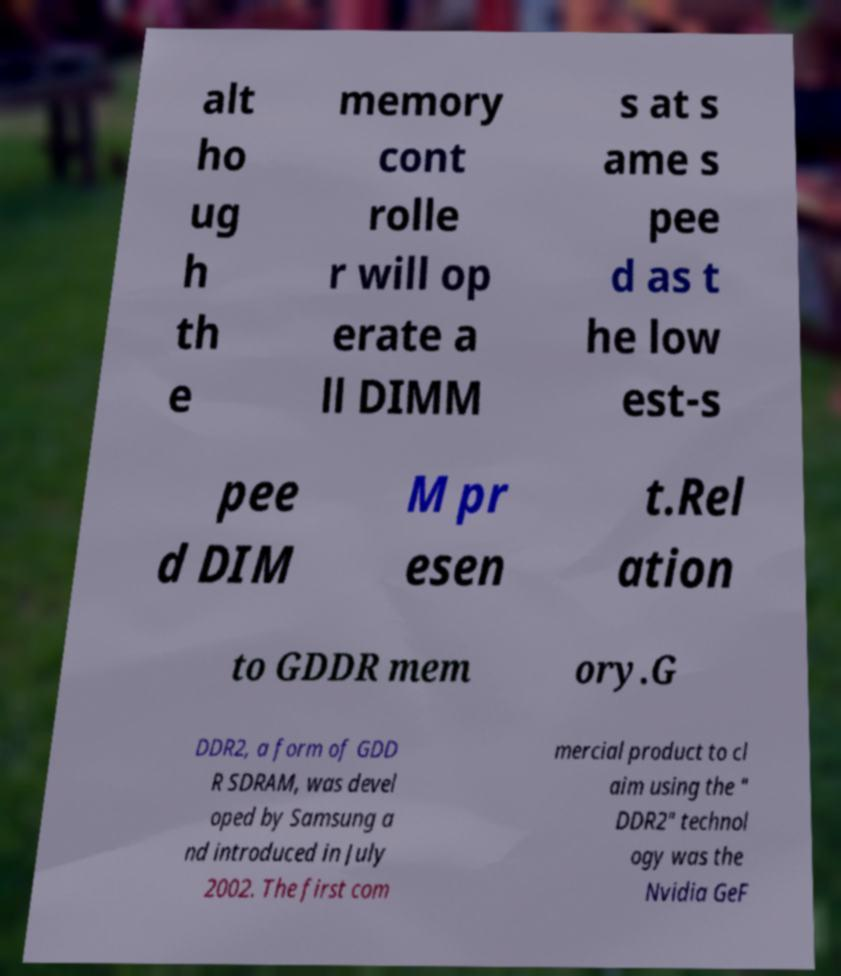Can you read and provide the text displayed in the image?This photo seems to have some interesting text. Can you extract and type it out for me? alt ho ug h th e memory cont rolle r will op erate a ll DIMM s at s ame s pee d as t he low est-s pee d DIM M pr esen t.Rel ation to GDDR mem ory.G DDR2, a form of GDD R SDRAM, was devel oped by Samsung a nd introduced in July 2002. The first com mercial product to cl aim using the " DDR2" technol ogy was the Nvidia GeF 